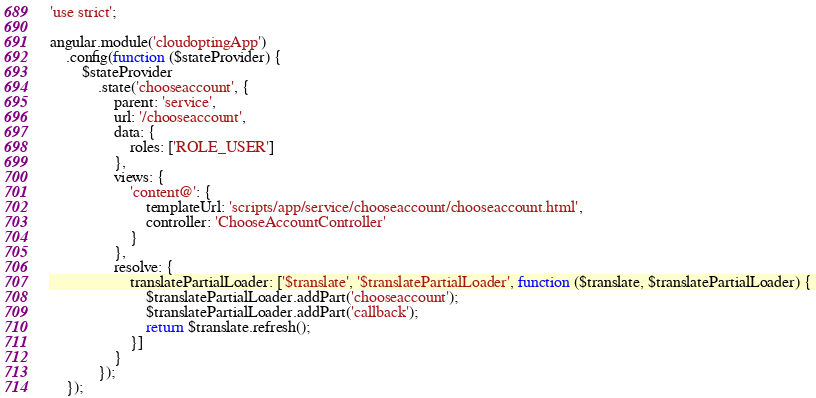<code> <loc_0><loc_0><loc_500><loc_500><_JavaScript_>'use strict';

angular.module('cloudoptingApp')
    .config(function ($stateProvider) {
        $stateProvider
            .state('chooseaccount', {
                parent: 'service',
                url: '/chooseaccount',
                data: {
                    roles: ['ROLE_USER']
                },
                views: {
                    'content@': {
                        templateUrl: 'scripts/app/service/chooseaccount/chooseaccount.html',
                        controller: 'ChooseAccountController'
                    }
                },
                resolve: {
                    translatePartialLoader: ['$translate', '$translatePartialLoader', function ($translate, $translatePartialLoader) {
                        $translatePartialLoader.addPart('chooseaccount');
                        $translatePartialLoader.addPart('callback');
                        return $translate.refresh();
                    }]
                }
            });
    });
</code> 